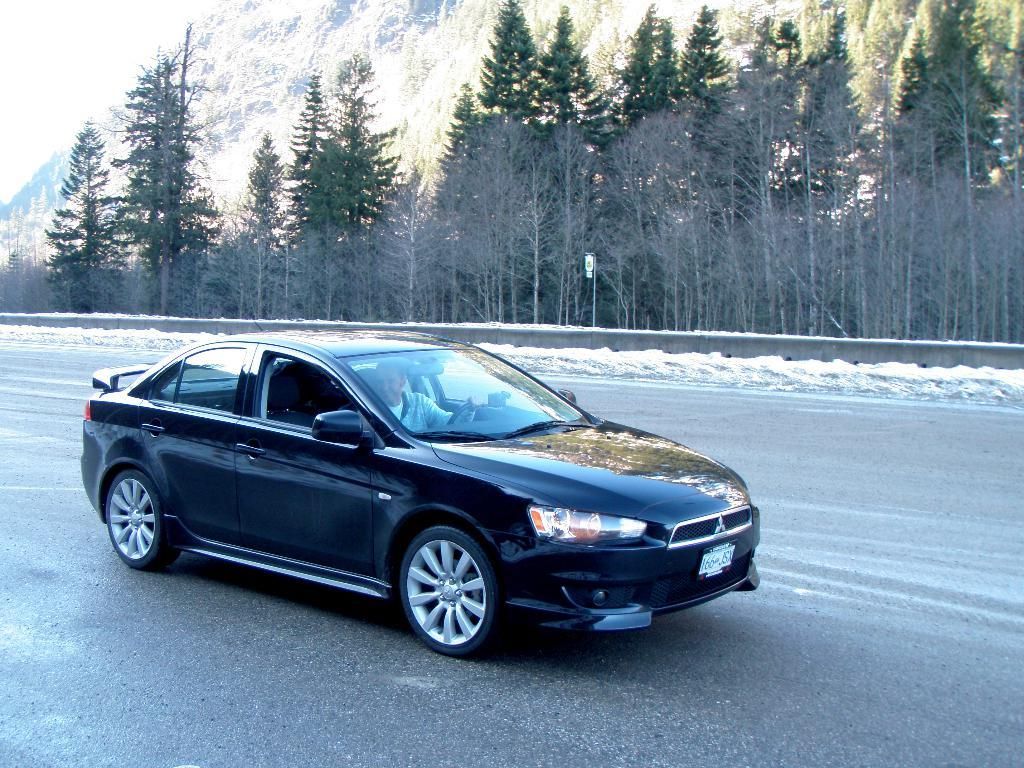What is the main subject in the foreground of the image? There is a black car in the foreground of the image. What is the car doing in the image? The car is moving on the road. What can be seen in the background of the image? There are trees, a pole, and the sky visible in the background of the image. Where is the nearest market to the car in the image? There is no information about a market in the image, so it cannot be determined from the image. 